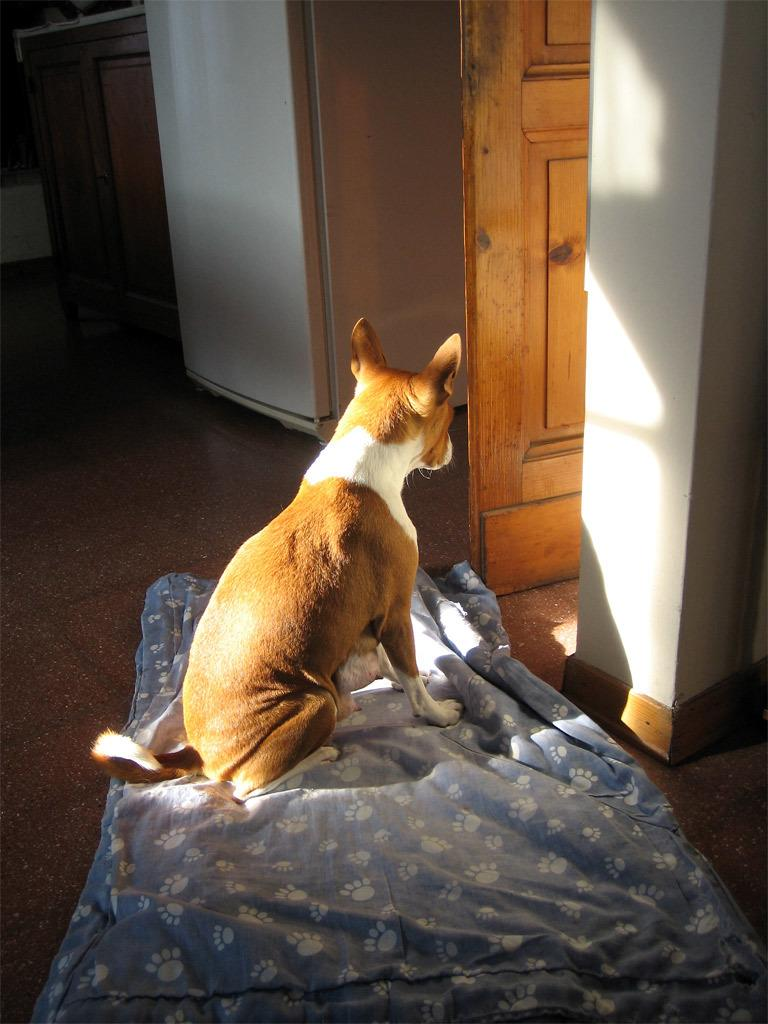What is the main setting of the image? The image is of a room. What can be seen in the foreground of the room? There is a dog sitting on a mat in the foreground. What objects are visible in the background of the room? There is a door, a table, and a fridge in the background. What type of surface is visible in the image? There is a floor visible in the image. What direction is the dog facing with the stick in the image? There is no stick present in the image, and the dog is not facing any particular direction. 